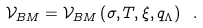Convert formula to latex. <formula><loc_0><loc_0><loc_500><loc_500>\mathcal { V } _ { B M } = \mathcal { V } _ { B M } \left ( \sigma , T , \xi , q _ { \Lambda } \right ) \text { } .</formula> 